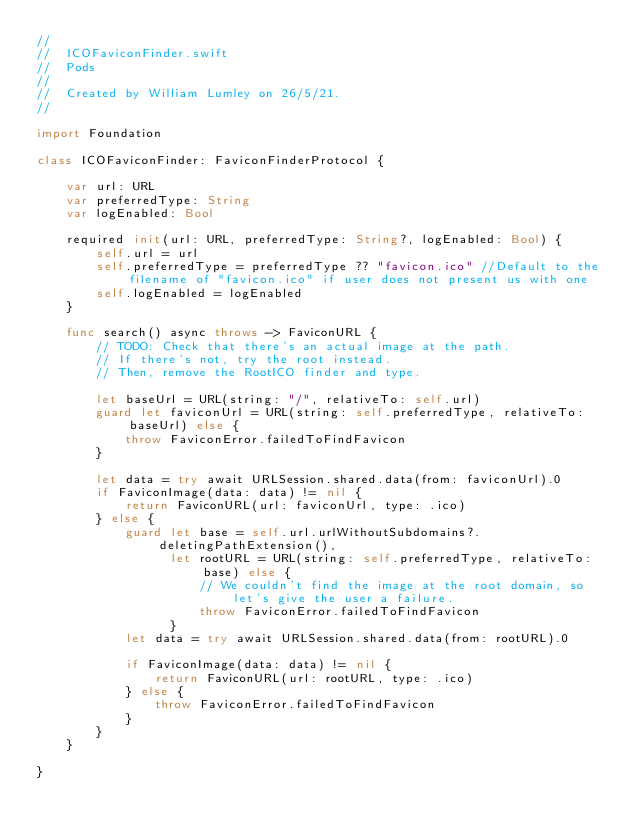Convert code to text. <code><loc_0><loc_0><loc_500><loc_500><_Swift_>//
//  ICOFaviconFinder.swift
//  Pods
//
//  Created by William Lumley on 26/5/21.
//

import Foundation

class ICOFaviconFinder: FaviconFinderProtocol {

    var url: URL
    var preferredType: String
    var logEnabled: Bool

    required init(url: URL, preferredType: String?, logEnabled: Bool) {
        self.url = url
        self.preferredType = preferredType ?? "favicon.ico" //Default to the filename of "favicon.ico" if user does not present us with one
        self.logEnabled = logEnabled
    }

    func search() async throws -> FaviconURL {
        // TODO: Check that there's an actual image at the path.
        // If there's not, try the root instead.
        // Then, remove the RootICO finder and type.

        let baseUrl = URL(string: "/", relativeTo: self.url)
        guard let faviconUrl = URL(string: self.preferredType, relativeTo: baseUrl) else {
            throw FaviconError.failedToFindFavicon
        }
        
        let data = try await URLSession.shared.data(from: faviconUrl).0
        if FaviconImage(data: data) != nil {
            return FaviconURL(url: faviconUrl, type: .ico)
        } else {
            guard let base = self.url.urlWithoutSubdomains?.deletingPathExtension(),
                  let rootURL = URL(string: self.preferredType, relativeTo: base) else {
                      // We couldn't find the image at the root domain, so let's give the user a failure.
                      throw FaviconError.failedToFindFavicon
                  }
            let data = try await URLSession.shared.data(from: rootURL).0
            
            if FaviconImage(data: data) != nil {
                return FaviconURL(url: rootURL, type: .ico)
            } else {
                throw FaviconError.failedToFindFavicon
            }
        }
    }

}
</code> 